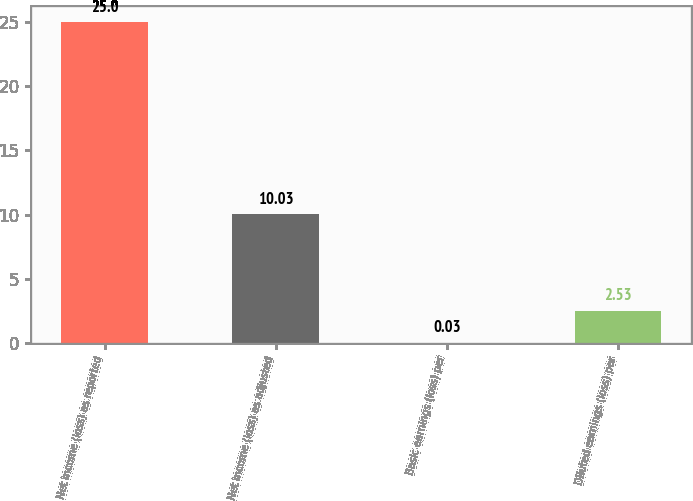<chart> <loc_0><loc_0><loc_500><loc_500><bar_chart><fcel>Net income (loss) as reported<fcel>Net income (loss) as adjusted<fcel>Basic earnings (loss) per<fcel>Diluted earnings (loss) per<nl><fcel>25<fcel>10.03<fcel>0.03<fcel>2.53<nl></chart> 